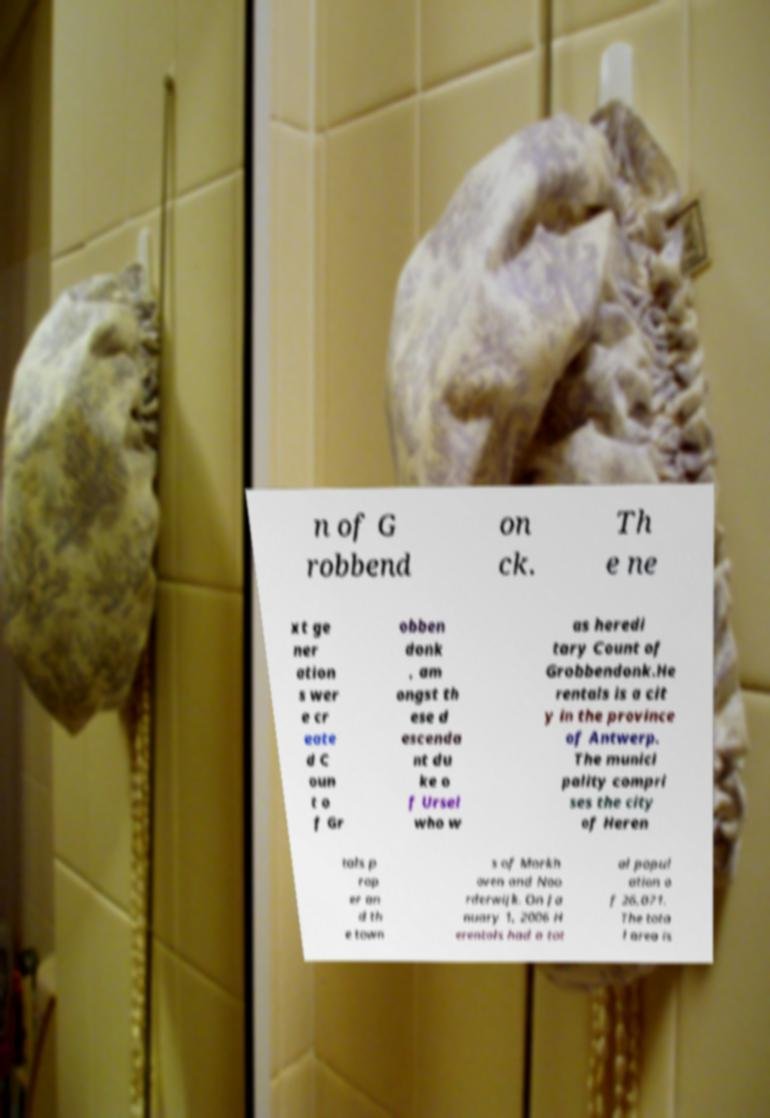Could you assist in decoding the text presented in this image and type it out clearly? n of G robbend on ck. Th e ne xt ge ner ation s wer e cr eate d C oun t o f Gr obben donk , am ongst th ese d escenda nt du ke o f Ursel who w as heredi tary Count of Grobbendonk.He rentals is a cit y in the province of Antwerp. The munici pality compri ses the city of Heren tals p rop er an d th e town s of Morkh oven and Noo rderwijk. On Ja nuary 1, 2006 H erentals had a tot al popul ation o f 26,071. The tota l area is 